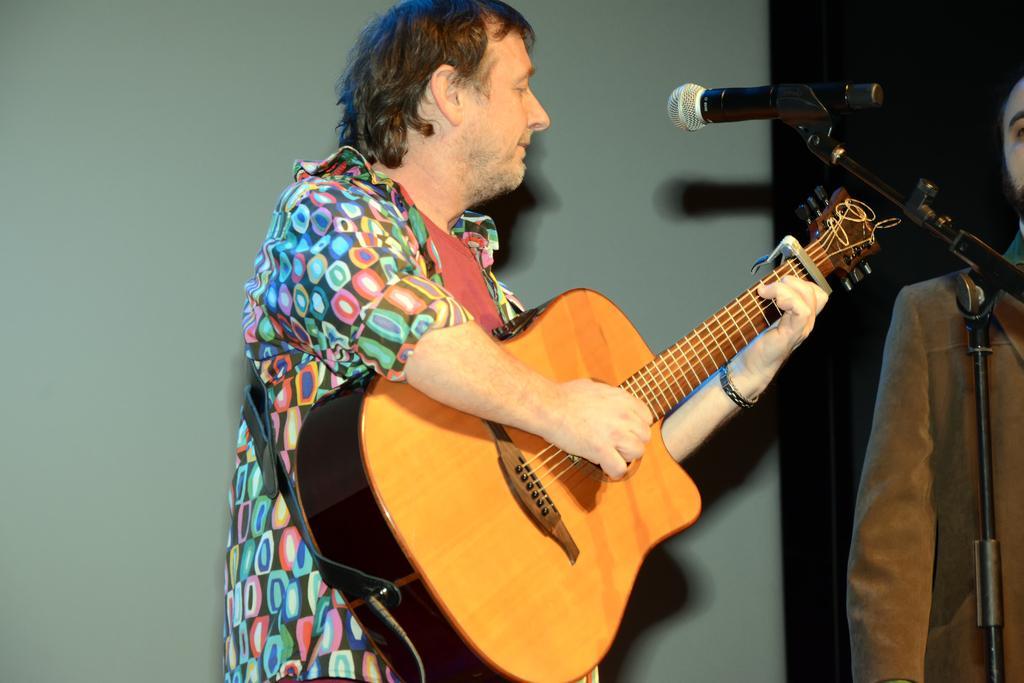In one or two sentences, can you explain what this image depicts? In this image I see 2 men and one of them is holding a guitar and there is a mic in front of him. In the background I see the wall. 